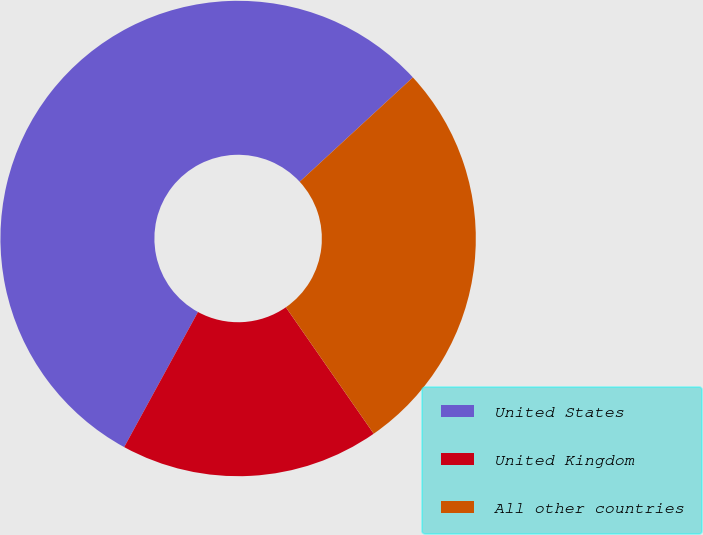Convert chart. <chart><loc_0><loc_0><loc_500><loc_500><pie_chart><fcel>United States<fcel>United Kingdom<fcel>All other countries<nl><fcel>55.19%<fcel>17.62%<fcel>27.19%<nl></chart> 